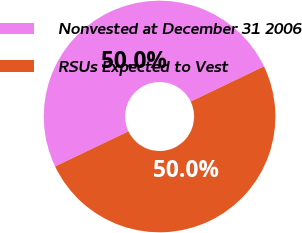Convert chart to OTSL. <chart><loc_0><loc_0><loc_500><loc_500><pie_chart><fcel>Nonvested at December 31 2006<fcel>RSUs Expected to Vest<nl><fcel>49.97%<fcel>50.03%<nl></chart> 